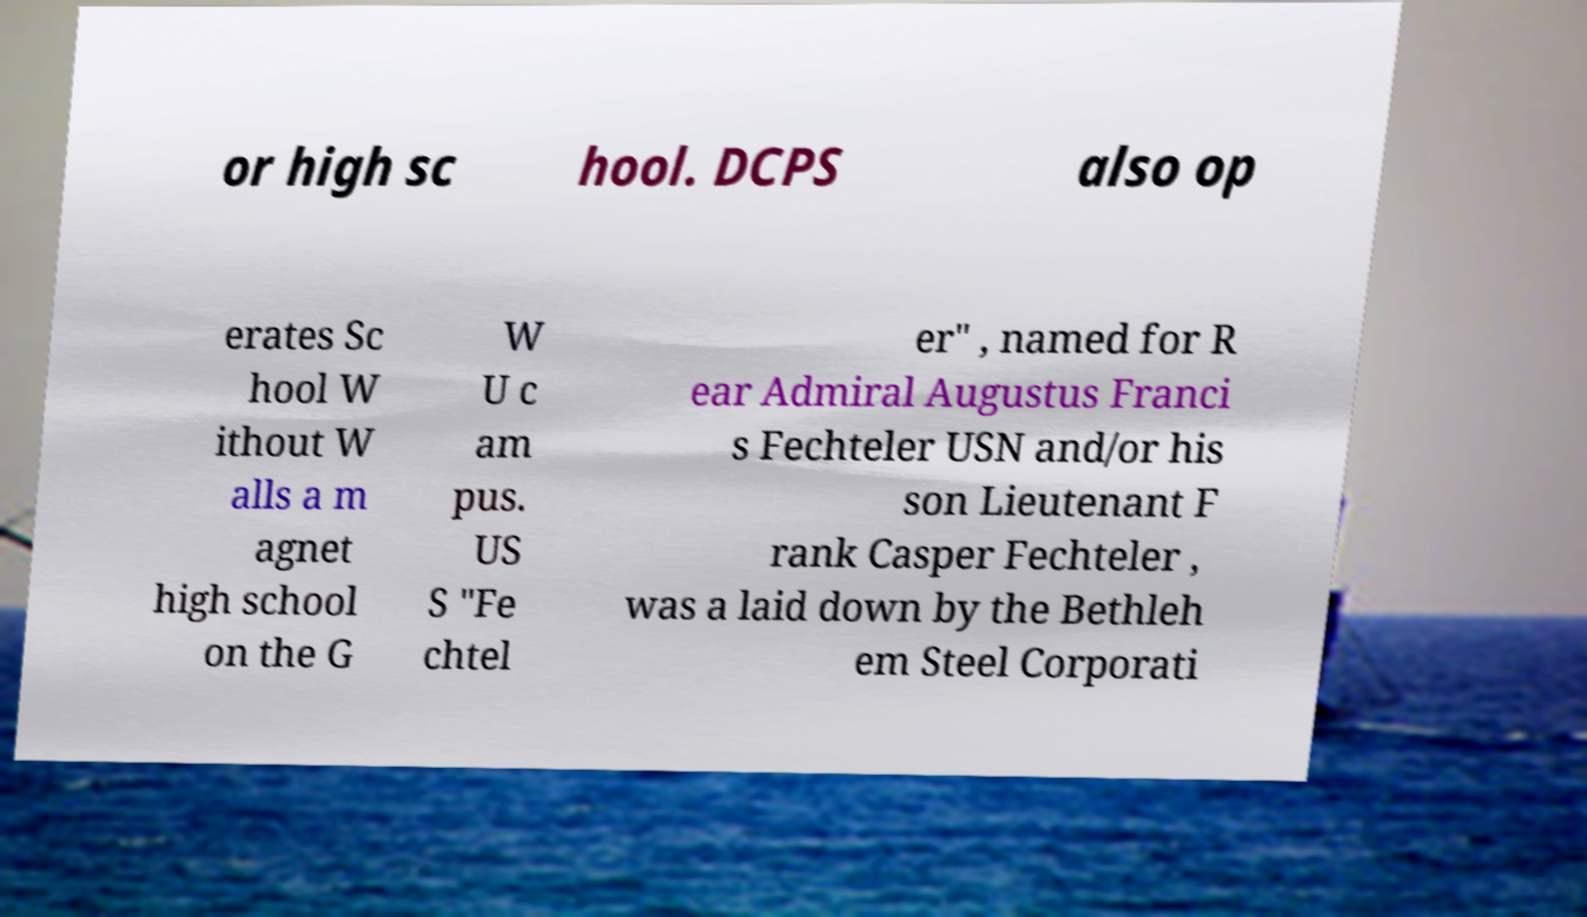Please read and relay the text visible in this image. What does it say? or high sc hool. DCPS also op erates Sc hool W ithout W alls a m agnet high school on the G W U c am pus. US S "Fe chtel er" , named for R ear Admiral Augustus Franci s Fechteler USN and/or his son Lieutenant F rank Casper Fechteler , was a laid down by the Bethleh em Steel Corporati 